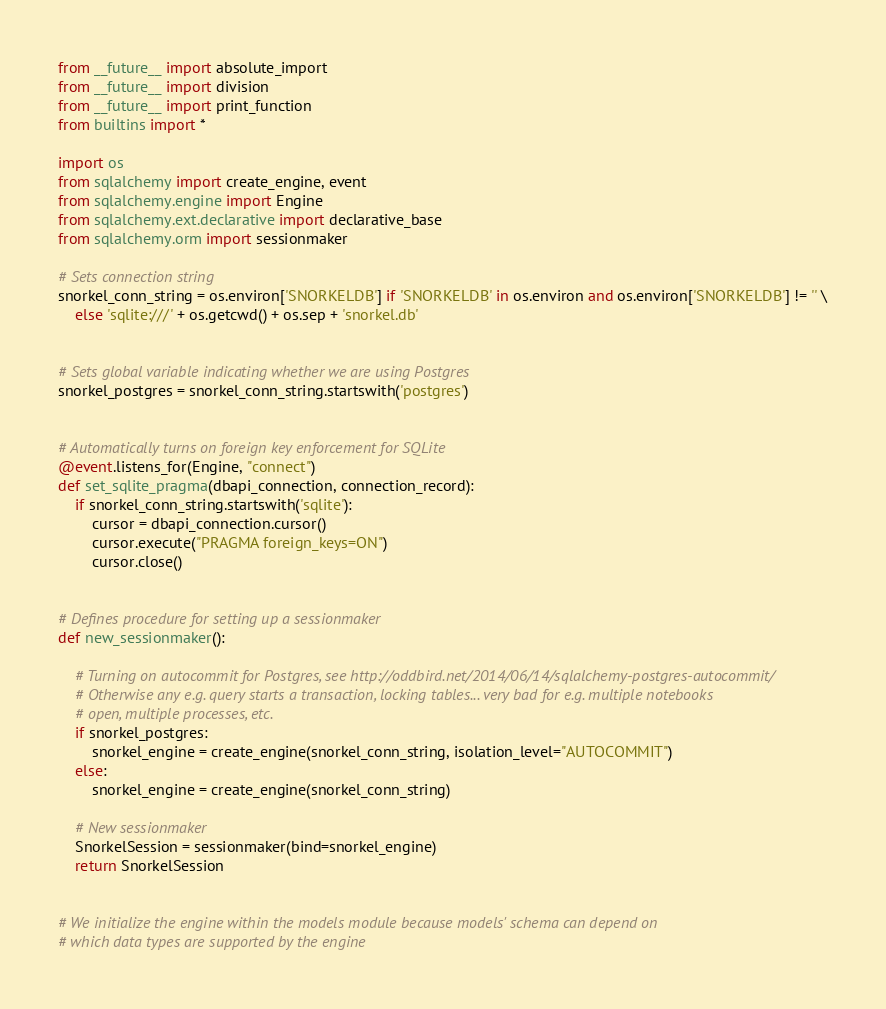<code> <loc_0><loc_0><loc_500><loc_500><_Python_>from __future__ import absolute_import
from __future__ import division
from __future__ import print_function
from builtins import *

import os
from sqlalchemy import create_engine, event
from sqlalchemy.engine import Engine
from sqlalchemy.ext.declarative import declarative_base
from sqlalchemy.orm import sessionmaker

# Sets connection string
snorkel_conn_string = os.environ['SNORKELDB'] if 'SNORKELDB' in os.environ and os.environ['SNORKELDB'] != '' \
    else 'sqlite:///' + os.getcwd() + os.sep + 'snorkel.db'


# Sets global variable indicating whether we are using Postgres
snorkel_postgres = snorkel_conn_string.startswith('postgres')


# Automatically turns on foreign key enforcement for SQLite
@event.listens_for(Engine, "connect")
def set_sqlite_pragma(dbapi_connection, connection_record):
    if snorkel_conn_string.startswith('sqlite'):
        cursor = dbapi_connection.cursor()
        cursor.execute("PRAGMA foreign_keys=ON")
        cursor.close()


# Defines procedure for setting up a sessionmaker
def new_sessionmaker():
    
    # Turning on autocommit for Postgres, see http://oddbird.net/2014/06/14/sqlalchemy-postgres-autocommit/
    # Otherwise any e.g. query starts a transaction, locking tables... very bad for e.g. multiple notebooks
    # open, multiple processes, etc.
    if snorkel_postgres:
        snorkel_engine = create_engine(snorkel_conn_string, isolation_level="AUTOCOMMIT")
    else:
        snorkel_engine = create_engine(snorkel_conn_string)

    # New sessionmaker
    SnorkelSession = sessionmaker(bind=snorkel_engine)
    return SnorkelSession


# We initialize the engine within the models module because models' schema can depend on
# which data types are supported by the engine</code> 